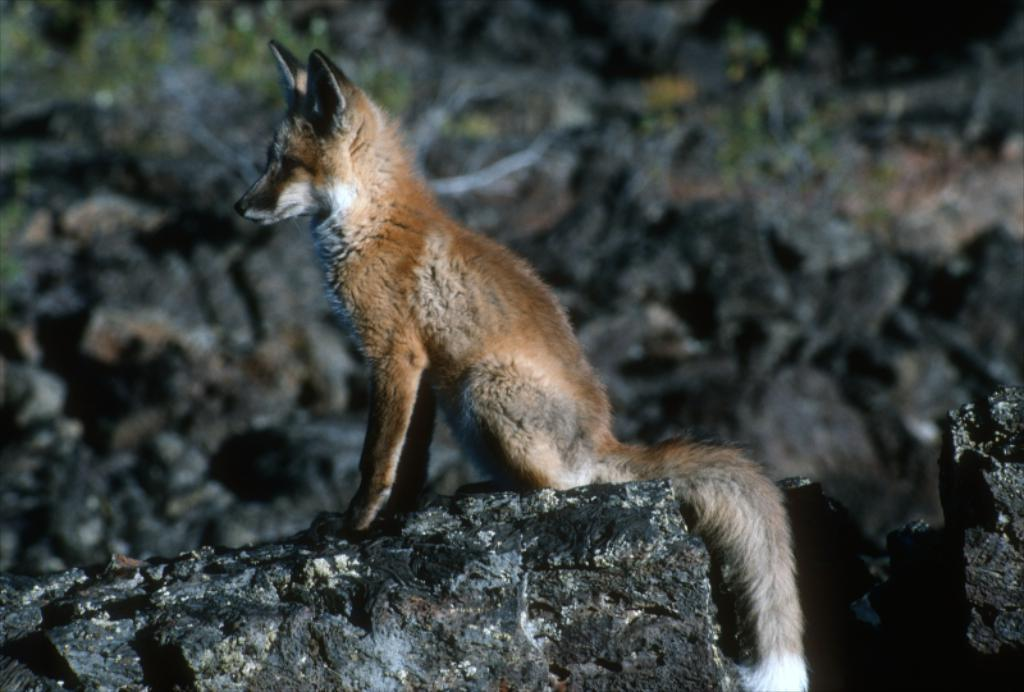What type of animal is in the image? The animal in the image is not specified, but it has brown and white colors. What can be seen in the background of the image? There are rocks visible in the image. What type of popcorn is being served at the summer event in the image? There is no popcorn, summer event, or sign present in the image. 